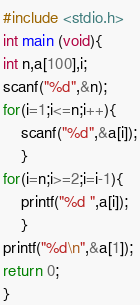Convert code to text. <code><loc_0><loc_0><loc_500><loc_500><_C_>#include <stdio.h>
int main (void){
int n,a[100],i;
scanf("%d",&n);
for(i=1;i<=n;i++){
	scanf("%d",&a[i]);
	}
for(i=n;i>=2;i=i-1){
	printf("%d ",a[i]);
	}
printf("%d\n",&a[1]);
return 0;	
}</code> 